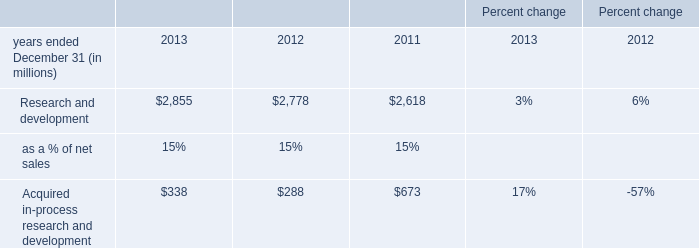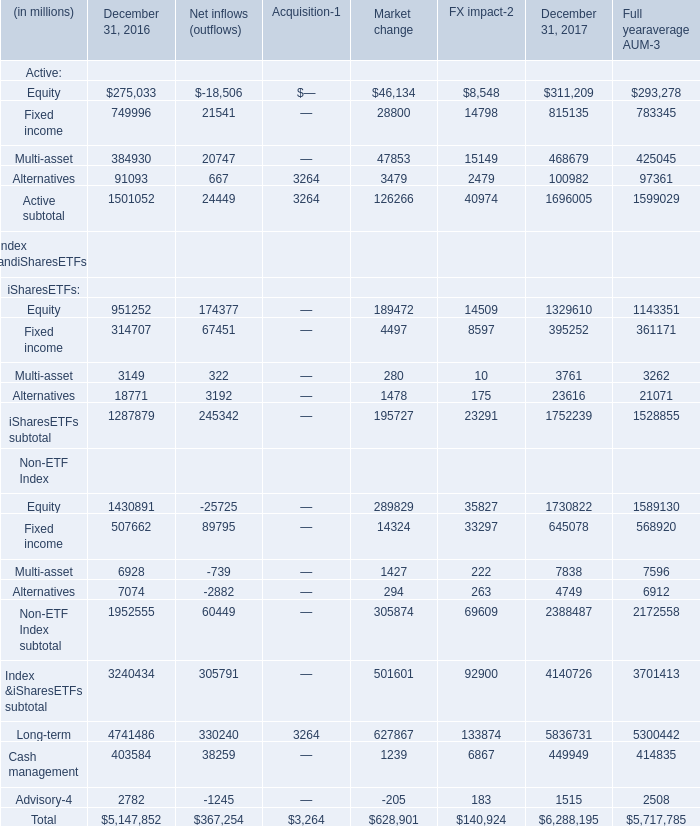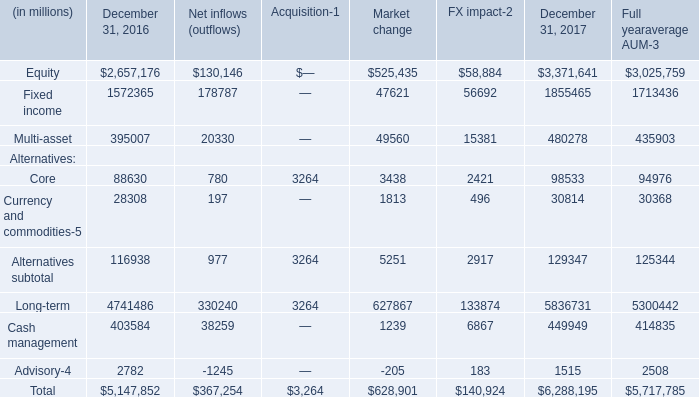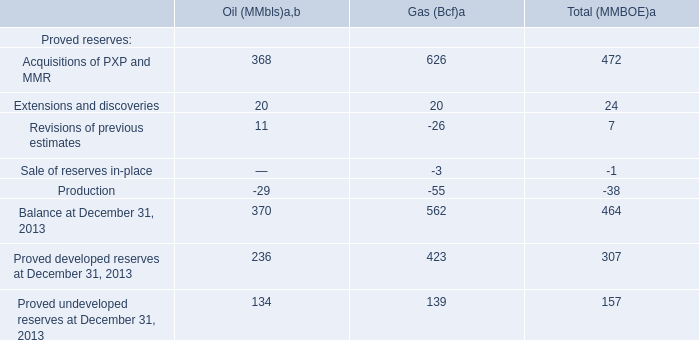What's the average of Equity and Fixed income in terms of December 31, 2016 in 2016? (in dollars in millions) 
Computations: ((2657176 + 1572365) / 2)
Answer: 2114770.5. 